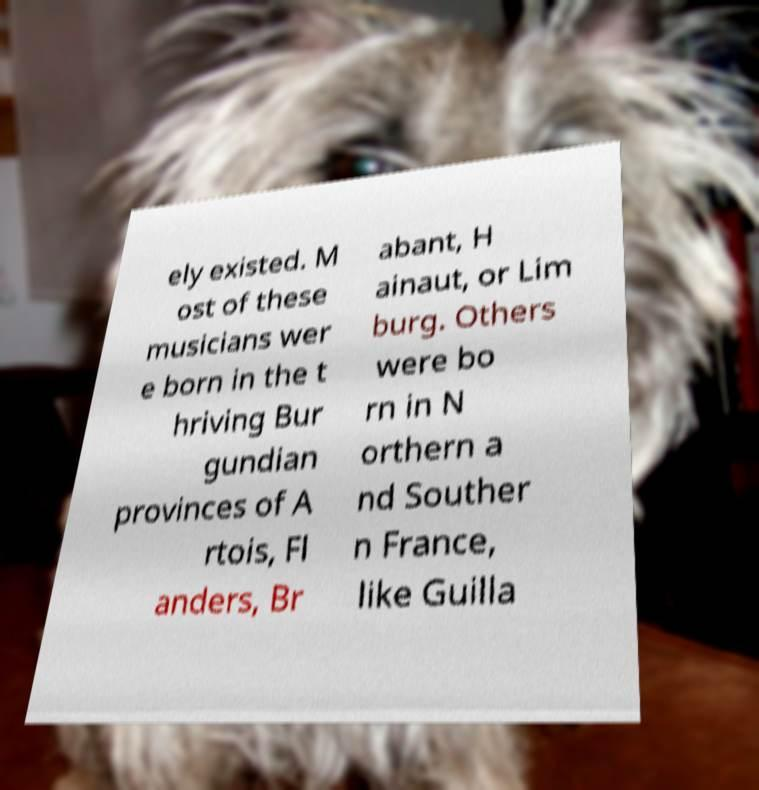There's text embedded in this image that I need extracted. Can you transcribe it verbatim? ely existed. M ost of these musicians wer e born in the t hriving Bur gundian provinces of A rtois, Fl anders, Br abant, H ainaut, or Lim burg. Others were bo rn in N orthern a nd Souther n France, like Guilla 